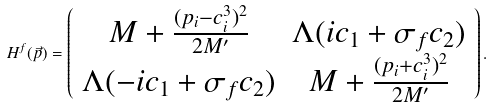Convert formula to latex. <formula><loc_0><loc_0><loc_500><loc_500>H ^ { f } ( \vec { p } ) = \left ( \begin{array} { c c } M + \frac { ( p _ { i } - c _ { i } ^ { 3 } ) ^ { 2 } } { 2 M ^ { \prime } } & \Lambda ( i c _ { 1 } + \sigma _ { f } c _ { 2 } ) \\ \Lambda ( - i c _ { 1 } + \sigma _ { f } c _ { 2 } ) & M + \frac { ( p _ { i } + c _ { i } ^ { 3 } ) ^ { 2 } } { 2 M ^ { \prime } } \end{array} \right ) .</formula> 